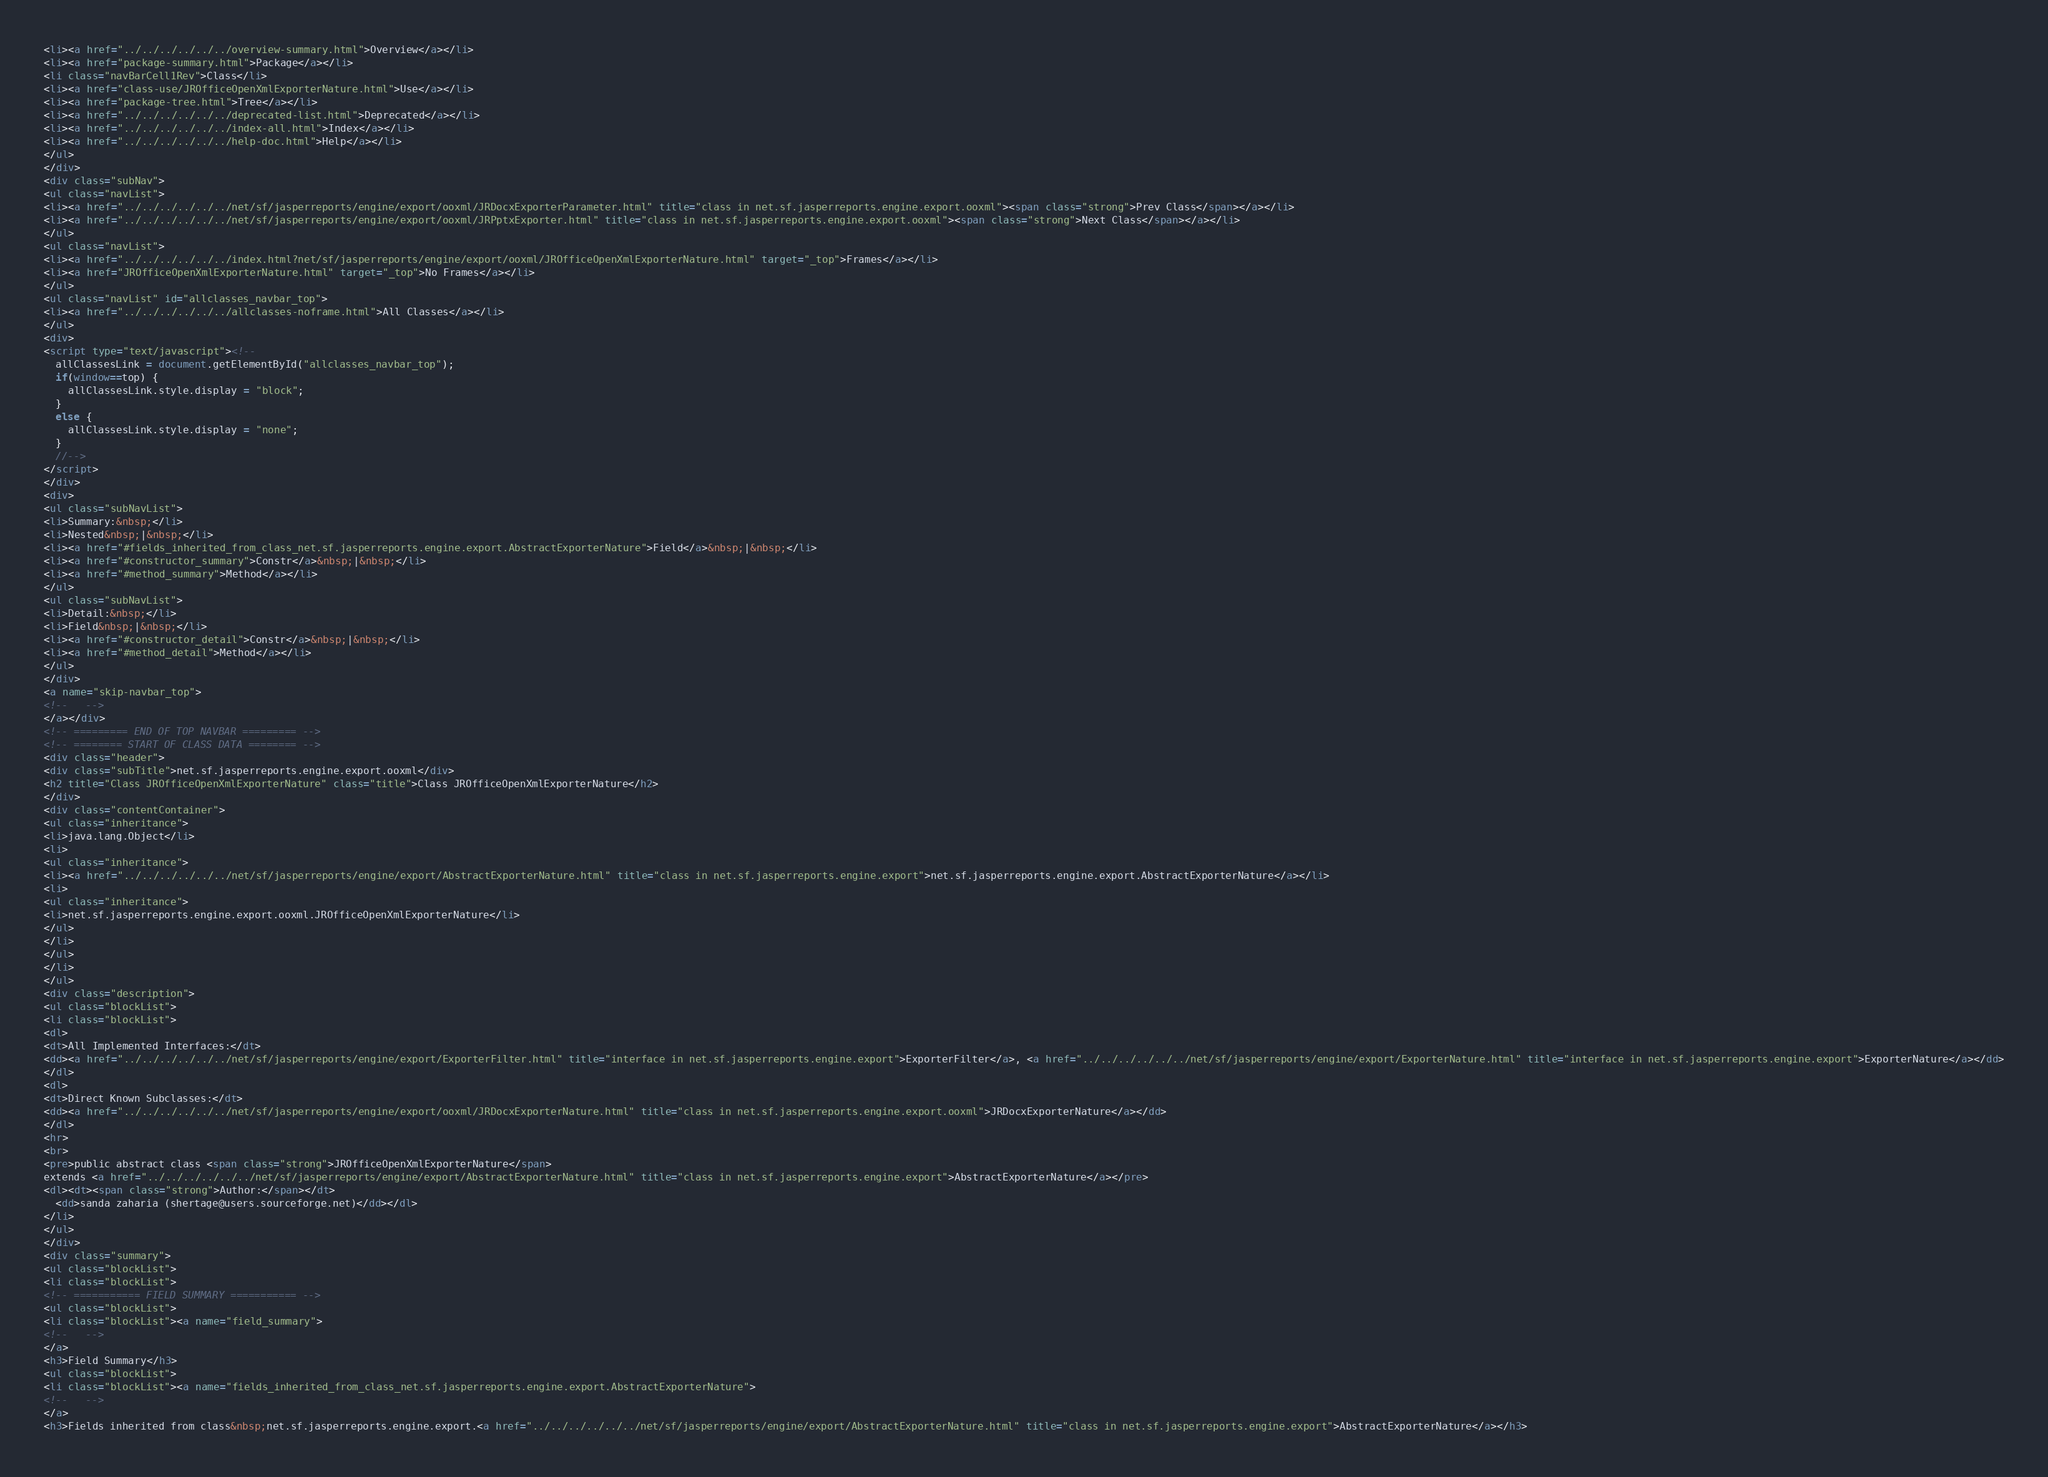Convert code to text. <code><loc_0><loc_0><loc_500><loc_500><_HTML_><li><a href="../../../../../../overview-summary.html">Overview</a></li>
<li><a href="package-summary.html">Package</a></li>
<li class="navBarCell1Rev">Class</li>
<li><a href="class-use/JROfficeOpenXmlExporterNature.html">Use</a></li>
<li><a href="package-tree.html">Tree</a></li>
<li><a href="../../../../../../deprecated-list.html">Deprecated</a></li>
<li><a href="../../../../../../index-all.html">Index</a></li>
<li><a href="../../../../../../help-doc.html">Help</a></li>
</ul>
</div>
<div class="subNav">
<ul class="navList">
<li><a href="../../../../../../net/sf/jasperreports/engine/export/ooxml/JRDocxExporterParameter.html" title="class in net.sf.jasperreports.engine.export.ooxml"><span class="strong">Prev Class</span></a></li>
<li><a href="../../../../../../net/sf/jasperreports/engine/export/ooxml/JRPptxExporter.html" title="class in net.sf.jasperreports.engine.export.ooxml"><span class="strong">Next Class</span></a></li>
</ul>
<ul class="navList">
<li><a href="../../../../../../index.html?net/sf/jasperreports/engine/export/ooxml/JROfficeOpenXmlExporterNature.html" target="_top">Frames</a></li>
<li><a href="JROfficeOpenXmlExporterNature.html" target="_top">No Frames</a></li>
</ul>
<ul class="navList" id="allclasses_navbar_top">
<li><a href="../../../../../../allclasses-noframe.html">All Classes</a></li>
</ul>
<div>
<script type="text/javascript"><!--
  allClassesLink = document.getElementById("allclasses_navbar_top");
  if(window==top) {
    allClassesLink.style.display = "block";
  }
  else {
    allClassesLink.style.display = "none";
  }
  //-->
</script>
</div>
<div>
<ul class="subNavList">
<li>Summary:&nbsp;</li>
<li>Nested&nbsp;|&nbsp;</li>
<li><a href="#fields_inherited_from_class_net.sf.jasperreports.engine.export.AbstractExporterNature">Field</a>&nbsp;|&nbsp;</li>
<li><a href="#constructor_summary">Constr</a>&nbsp;|&nbsp;</li>
<li><a href="#method_summary">Method</a></li>
</ul>
<ul class="subNavList">
<li>Detail:&nbsp;</li>
<li>Field&nbsp;|&nbsp;</li>
<li><a href="#constructor_detail">Constr</a>&nbsp;|&nbsp;</li>
<li><a href="#method_detail">Method</a></li>
</ul>
</div>
<a name="skip-navbar_top">
<!--   -->
</a></div>
<!-- ========= END OF TOP NAVBAR ========= -->
<!-- ======== START OF CLASS DATA ======== -->
<div class="header">
<div class="subTitle">net.sf.jasperreports.engine.export.ooxml</div>
<h2 title="Class JROfficeOpenXmlExporterNature" class="title">Class JROfficeOpenXmlExporterNature</h2>
</div>
<div class="contentContainer">
<ul class="inheritance">
<li>java.lang.Object</li>
<li>
<ul class="inheritance">
<li><a href="../../../../../../net/sf/jasperreports/engine/export/AbstractExporterNature.html" title="class in net.sf.jasperreports.engine.export">net.sf.jasperreports.engine.export.AbstractExporterNature</a></li>
<li>
<ul class="inheritance">
<li>net.sf.jasperreports.engine.export.ooxml.JROfficeOpenXmlExporterNature</li>
</ul>
</li>
</ul>
</li>
</ul>
<div class="description">
<ul class="blockList">
<li class="blockList">
<dl>
<dt>All Implemented Interfaces:</dt>
<dd><a href="../../../../../../net/sf/jasperreports/engine/export/ExporterFilter.html" title="interface in net.sf.jasperreports.engine.export">ExporterFilter</a>, <a href="../../../../../../net/sf/jasperreports/engine/export/ExporterNature.html" title="interface in net.sf.jasperreports.engine.export">ExporterNature</a></dd>
</dl>
<dl>
<dt>Direct Known Subclasses:</dt>
<dd><a href="../../../../../../net/sf/jasperreports/engine/export/ooxml/JRDocxExporterNature.html" title="class in net.sf.jasperreports.engine.export.ooxml">JRDocxExporterNature</a></dd>
</dl>
<hr>
<br>
<pre>public abstract class <span class="strong">JROfficeOpenXmlExporterNature</span>
extends <a href="../../../../../../net/sf/jasperreports/engine/export/AbstractExporterNature.html" title="class in net.sf.jasperreports.engine.export">AbstractExporterNature</a></pre>
<dl><dt><span class="strong">Author:</span></dt>
  <dd>sanda zaharia (shertage@users.sourceforge.net)</dd></dl>
</li>
</ul>
</div>
<div class="summary">
<ul class="blockList">
<li class="blockList">
<!-- =========== FIELD SUMMARY =========== -->
<ul class="blockList">
<li class="blockList"><a name="field_summary">
<!--   -->
</a>
<h3>Field Summary</h3>
<ul class="blockList">
<li class="blockList"><a name="fields_inherited_from_class_net.sf.jasperreports.engine.export.AbstractExporterNature">
<!--   -->
</a>
<h3>Fields inherited from class&nbsp;net.sf.jasperreports.engine.export.<a href="../../../../../../net/sf/jasperreports/engine/export/AbstractExporterNature.html" title="class in net.sf.jasperreports.engine.export">AbstractExporterNature</a></h3></code> 